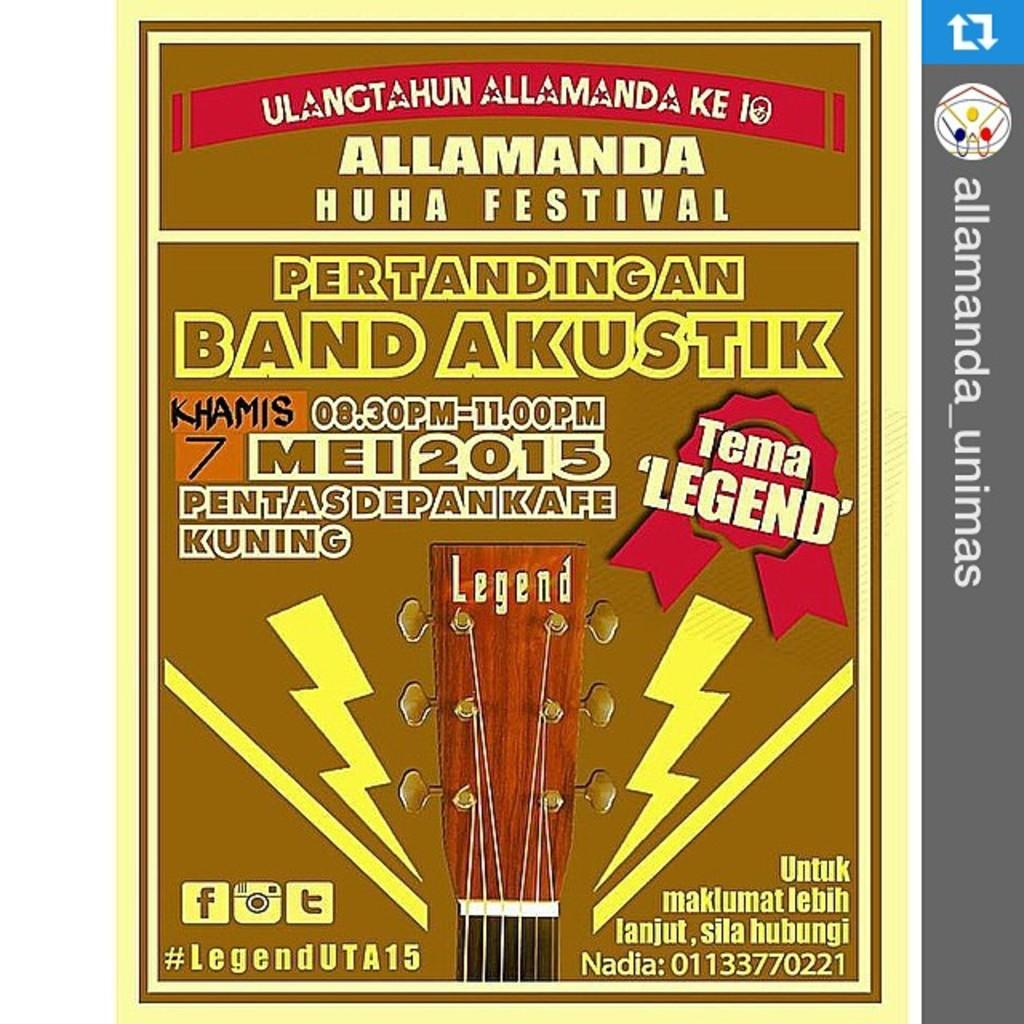<image>
Give a short and clear explanation of the subsequent image. A Legend guitar head is found on the cover of a festival program. 